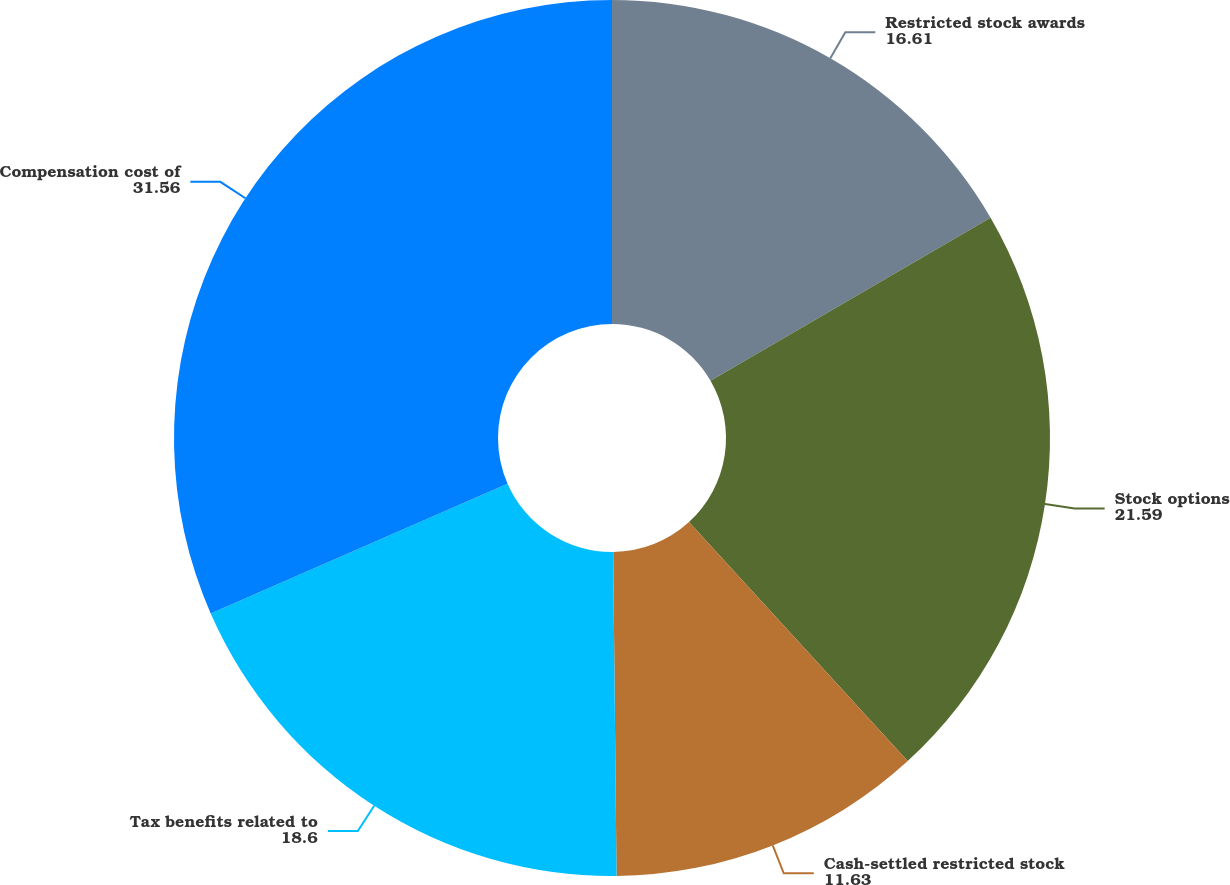<chart> <loc_0><loc_0><loc_500><loc_500><pie_chart><fcel>Restricted stock awards<fcel>Stock options<fcel>Cash-settled restricted stock<fcel>Tax benefits related to<fcel>Compensation cost of<nl><fcel>16.61%<fcel>21.59%<fcel>11.63%<fcel>18.6%<fcel>31.56%<nl></chart> 